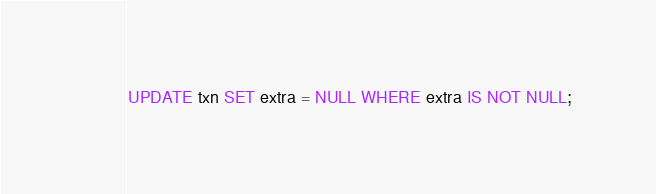Convert code to text. <code><loc_0><loc_0><loc_500><loc_500><_SQL_>UPDATE txn SET extra = NULL WHERE extra IS NOT NULL;
</code> 